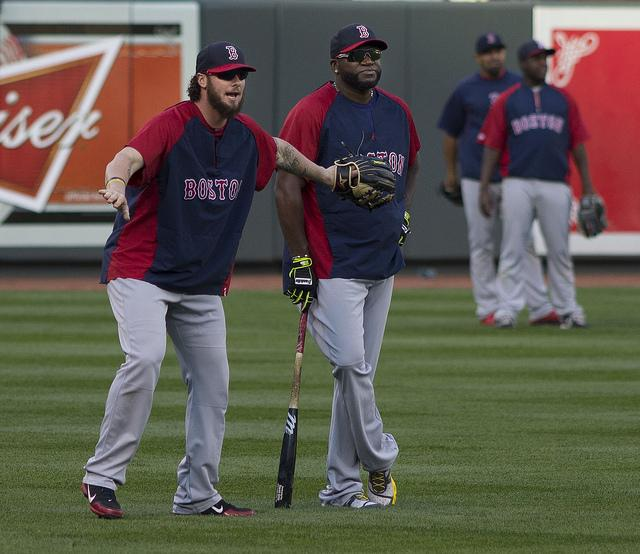What team do the men on the field play for?

Choices:
A) mets
B) yankees
C) rays
D) red sox red sox 